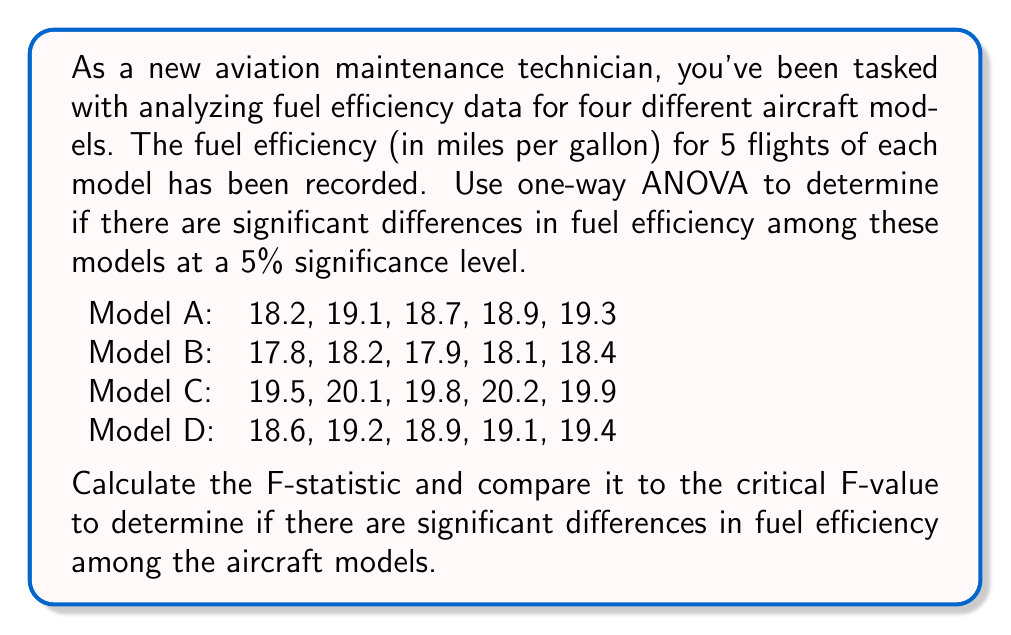Can you solve this math problem? To solve this problem using one-way ANOVA, we'll follow these steps:

1. Calculate the mean for each group and the overall mean.
2. Calculate the sum of squares between groups (SSB) and within groups (SSW).
3. Calculate the degrees of freedom for between groups (dfB) and within groups (dfW).
4. Calculate the mean square between groups (MSB) and within groups (MSW).
5. Calculate the F-statistic.
6. Determine the critical F-value.
7. Compare the F-statistic to the critical F-value.

Step 1: Calculate means
Model A mean: $\bar{X}_A = 18.84$
Model B mean: $\bar{X}_B = 18.08$
Model C mean: $\bar{X}_C = 19.90$
Model D mean: $\bar{X}_D = 19.04$
Overall mean: $\bar{X} = 18.965$

Step 2: Calculate sum of squares
SSB = $\sum_{i=1}^{k} n_i(\bar{X}_i - \bar{X})^2$
    = $5(18.84 - 18.965)^2 + 5(18.08 - 18.965)^2 + 5(19.90 - 18.965)^2 + 5(19.04 - 18.965)^2$
    = $11.0625$

SSW = $\sum_{i=1}^{k} \sum_{j=1}^{n_i} (X_{ij} - \bar{X}_i)^2$
    = $0.6280 + 0.2680 + 0.2780 + 0.3280$
    = $1.5020$

Step 3: Calculate degrees of freedom
dfB = $k - 1 = 4 - 1 = 3$
dfW = $N - k = 20 - 4 = 16$

Step 4: Calculate mean squares
MSB = $\frac{SSB}{dfB} = \frac{11.0625}{3} = 3.6875$
MSW = $\frac{SSW}{dfW} = \frac{1.5020}{16} = 0.0939$

Step 5: Calculate F-statistic
$F = \frac{MSB}{MSW} = \frac{3.6875}{0.0939} = 39.2705$

Step 6: Determine critical F-value
For $\alpha = 0.05$, dfB = 3, and dfW = 16, the critical F-value is approximately 3.2389.

Step 7: Compare F-statistic to critical F-value
Since $39.2705 > 3.2389$, we reject the null hypothesis.
Answer: F-statistic = 39.2705. Since the calculated F-statistic (39.2705) is greater than the critical F-value (3.2389), we conclude that there are significant differences in fuel efficiency among the aircraft models at the 5% significance level. 